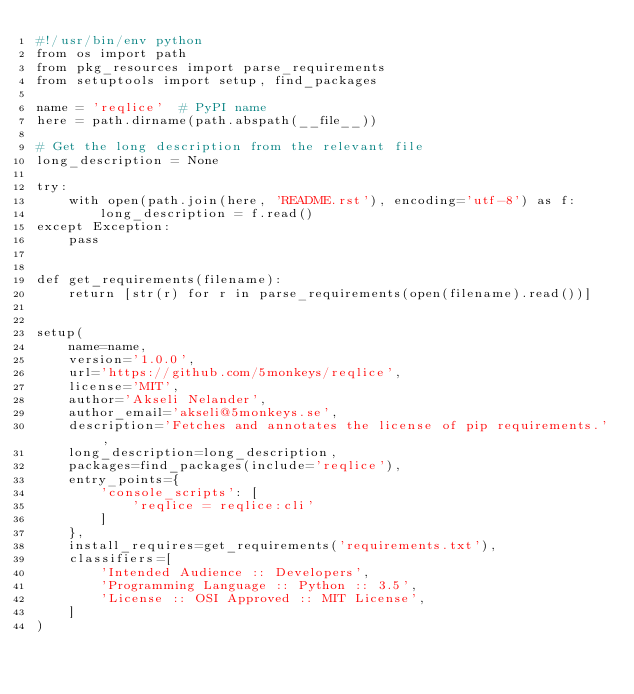Convert code to text. <code><loc_0><loc_0><loc_500><loc_500><_Python_>#!/usr/bin/env python
from os import path
from pkg_resources import parse_requirements
from setuptools import setup, find_packages

name = 'reqlice'  # PyPI name
here = path.dirname(path.abspath(__file__))

# Get the long description from the relevant file
long_description = None

try:
    with open(path.join(here, 'README.rst'), encoding='utf-8') as f:
        long_description = f.read()
except Exception:
    pass


def get_requirements(filename):
    return [str(r) for r in parse_requirements(open(filename).read())]


setup(
    name=name,
    version='1.0.0',
    url='https://github.com/5monkeys/reqlice',
    license='MIT',
    author='Akseli Nelander',
    author_email='akseli@5monkeys.se',
    description='Fetches and annotates the license of pip requirements.',
    long_description=long_description,
    packages=find_packages(include='reqlice'),
    entry_points={
        'console_scripts': [
            'reqlice = reqlice:cli'
        ]
    },
    install_requires=get_requirements('requirements.txt'),
    classifiers=[
        'Intended Audience :: Developers',
        'Programming Language :: Python :: 3.5',
        'License :: OSI Approved :: MIT License',
    ]
)
</code> 